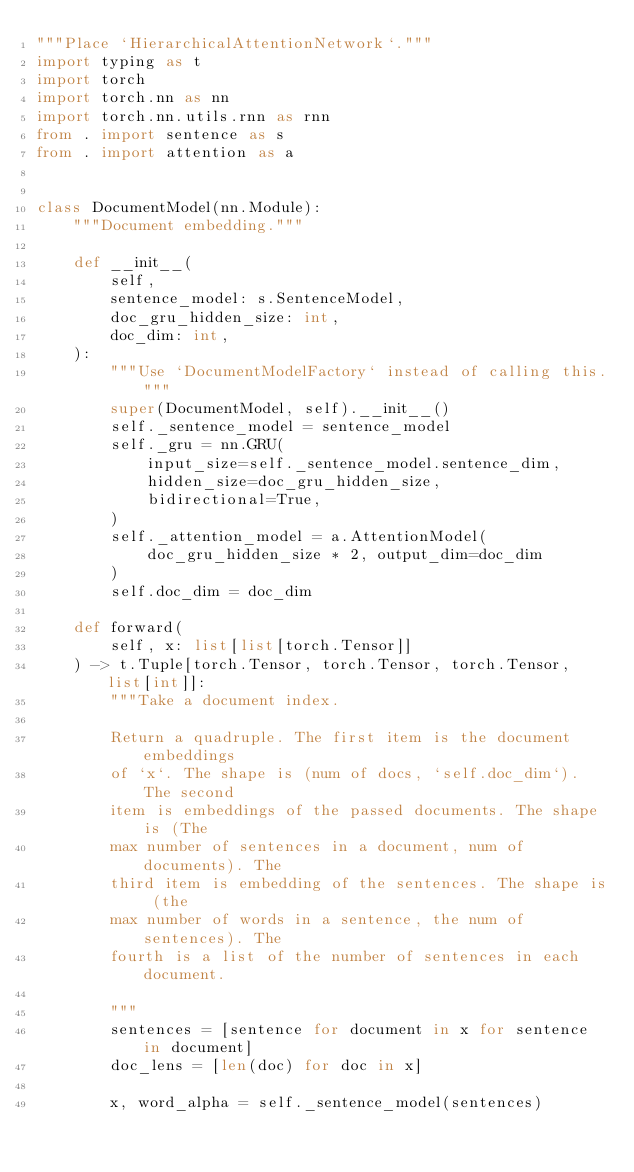Convert code to text. <code><loc_0><loc_0><loc_500><loc_500><_Python_>"""Place `HierarchicalAttentionNetwork`."""
import typing as t
import torch
import torch.nn as nn
import torch.nn.utils.rnn as rnn
from . import sentence as s
from . import attention as a


class DocumentModel(nn.Module):
    """Document embedding."""

    def __init__(
        self,
        sentence_model: s.SentenceModel,
        doc_gru_hidden_size: int,
        doc_dim: int,
    ):
        """Use `DocumentModelFactory` instead of calling this."""
        super(DocumentModel, self).__init__()
        self._sentence_model = sentence_model
        self._gru = nn.GRU(
            input_size=self._sentence_model.sentence_dim,
            hidden_size=doc_gru_hidden_size,
            bidirectional=True,
        )
        self._attention_model = a.AttentionModel(
            doc_gru_hidden_size * 2, output_dim=doc_dim
        )
        self.doc_dim = doc_dim

    def forward(
        self, x: list[list[torch.Tensor]]
    ) -> t.Tuple[torch.Tensor, torch.Tensor, torch.Tensor, list[int]]:
        """Take a document index.

        Return a quadruple. The first item is the document embeddings
        of `x`. The shape is (num of docs, `self.doc_dim`). The second
        item is embeddings of the passed documents. The shape is (The
        max number of sentences in a document, num of documents). The
        third item is embedding of the sentences. The shape is (the
        max number of words in a sentence, the num of sentences). The
        fourth is a list of the number of sentences in each document.

        """
        sentences = [sentence for document in x for sentence in document]
        doc_lens = [len(doc) for doc in x]

        x, word_alpha = self._sentence_model(sentences)</code> 